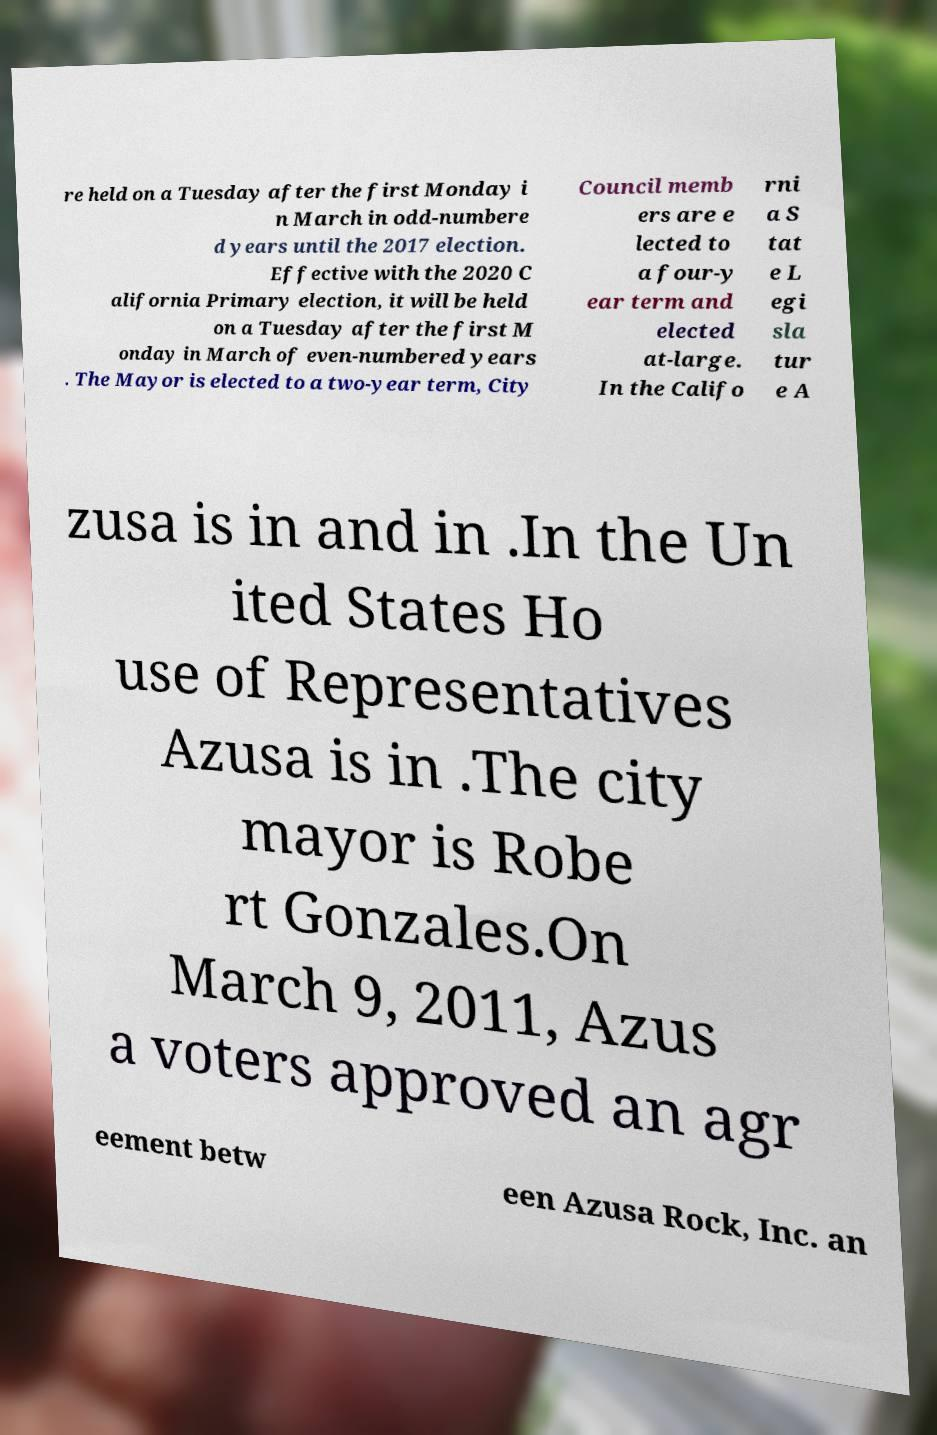There's text embedded in this image that I need extracted. Can you transcribe it verbatim? re held on a Tuesday after the first Monday i n March in odd-numbere d years until the 2017 election. Effective with the 2020 C alifornia Primary election, it will be held on a Tuesday after the first M onday in March of even-numbered years . The Mayor is elected to a two-year term, City Council memb ers are e lected to a four-y ear term and elected at-large. In the Califo rni a S tat e L egi sla tur e A zusa is in and in .In the Un ited States Ho use of Representatives Azusa is in .The city mayor is Robe rt Gonzales.On March 9, 2011, Azus a voters approved an agr eement betw een Azusa Rock, Inc. an 